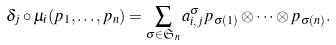Convert formula to latex. <formula><loc_0><loc_0><loc_500><loc_500>\delta _ { j } \circ \mu _ { i } ( p _ { 1 } , \dots , p _ { n } ) = \sum _ { \sigma \in \mathfrak { S } _ { n } } a _ { i , j } ^ { \sigma } p _ { \sigma ( 1 ) } \otimes \dots \otimes p _ { \sigma ( n ) } .</formula> 